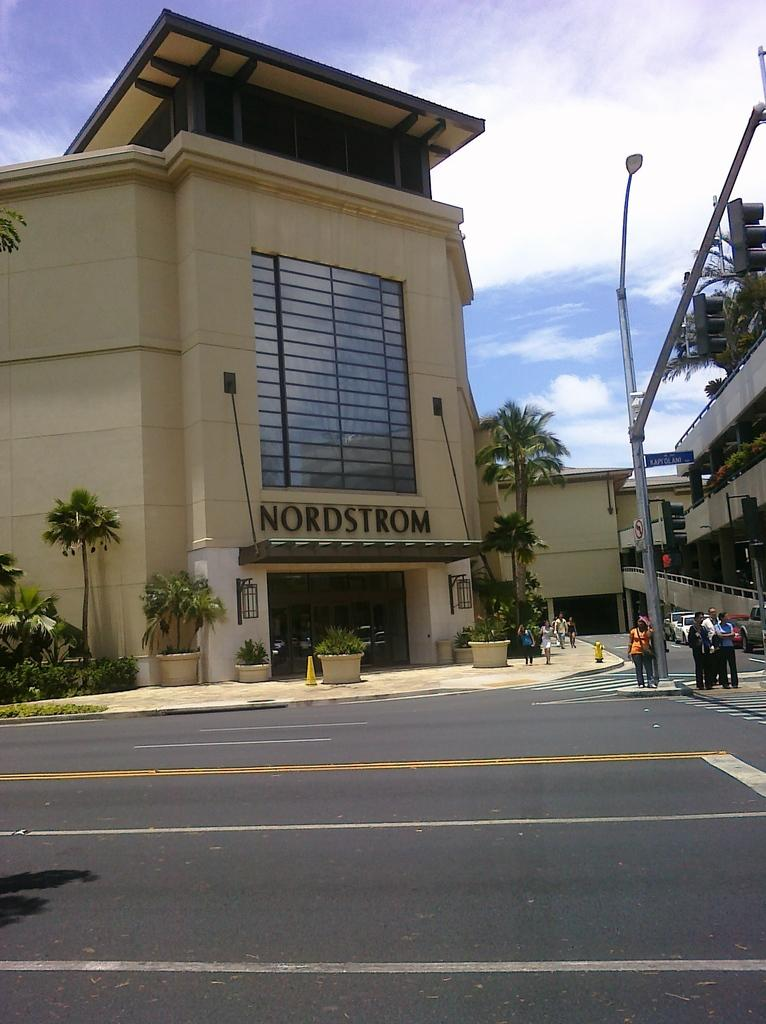<image>
Relay a brief, clear account of the picture shown. Nordstrom building at a mall with people standing in front 